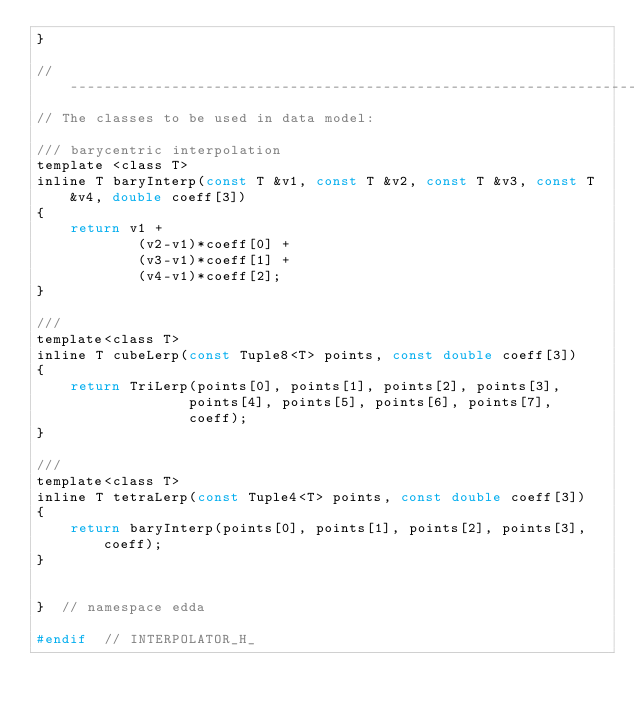Convert code to text. <code><loc_0><loc_0><loc_500><loc_500><_C_>}

//-----------------------------------------------------------------------------------------
// The classes to be used in data model:

/// barycentric interpolation
template <class T>
inline T baryInterp(const T &v1, const T &v2, const T &v3, const T &v4, double coeff[3])
{
    return v1 +
            (v2-v1)*coeff[0] +
            (v3-v1)*coeff[1] +
            (v4-v1)*coeff[2];
}

///
template<class T>
inline T cubeLerp(const Tuple8<T> points, const double coeff[3])
{
    return TriLerp(points[0], points[1], points[2], points[3],
                  points[4], points[5], points[6], points[7],
                  coeff);
}

///
template<class T>
inline T tetraLerp(const Tuple4<T> points, const double coeff[3])
{
    return baryInterp(points[0], points[1], points[2], points[3], coeff);
}


}  // namespace edda

#endif  // INTERPOLATOR_H_
</code> 